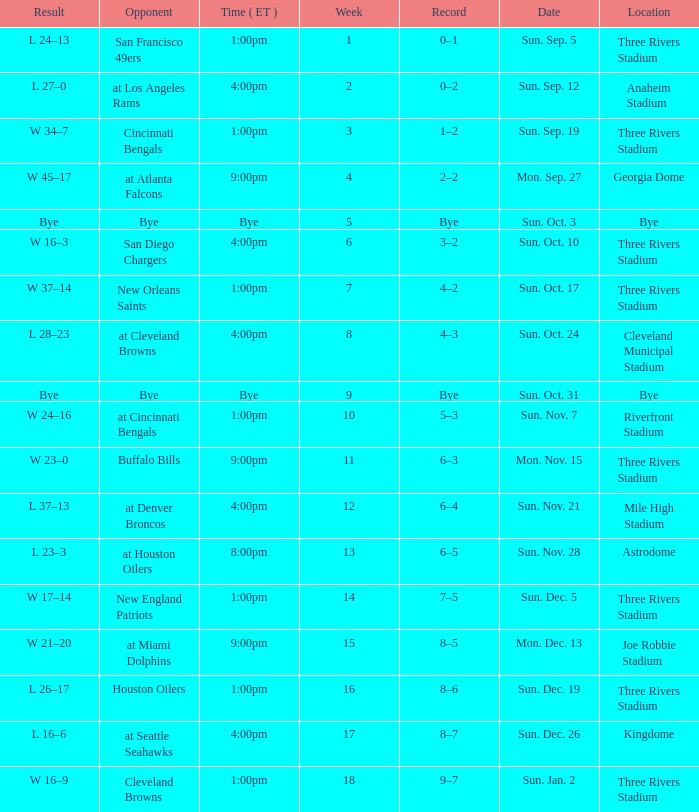What is the average Week for the game at three rivers stadium, with a Record of 3–2? 6.0. 